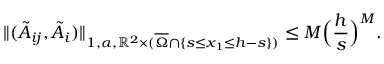<formula> <loc_0><loc_0><loc_500><loc_500>\| ( \tilde { A } _ { i j } , \tilde { A } _ { i } ) \| _ { 1 , \alpha , \mathbb { R } ^ { 2 } \times ( \overline { \Omega } \cap \{ s \leq x _ { 1 } \leq h - s \} ) } \leq M \left ( \frac { h } { s } \right ) ^ { M } .</formula> 